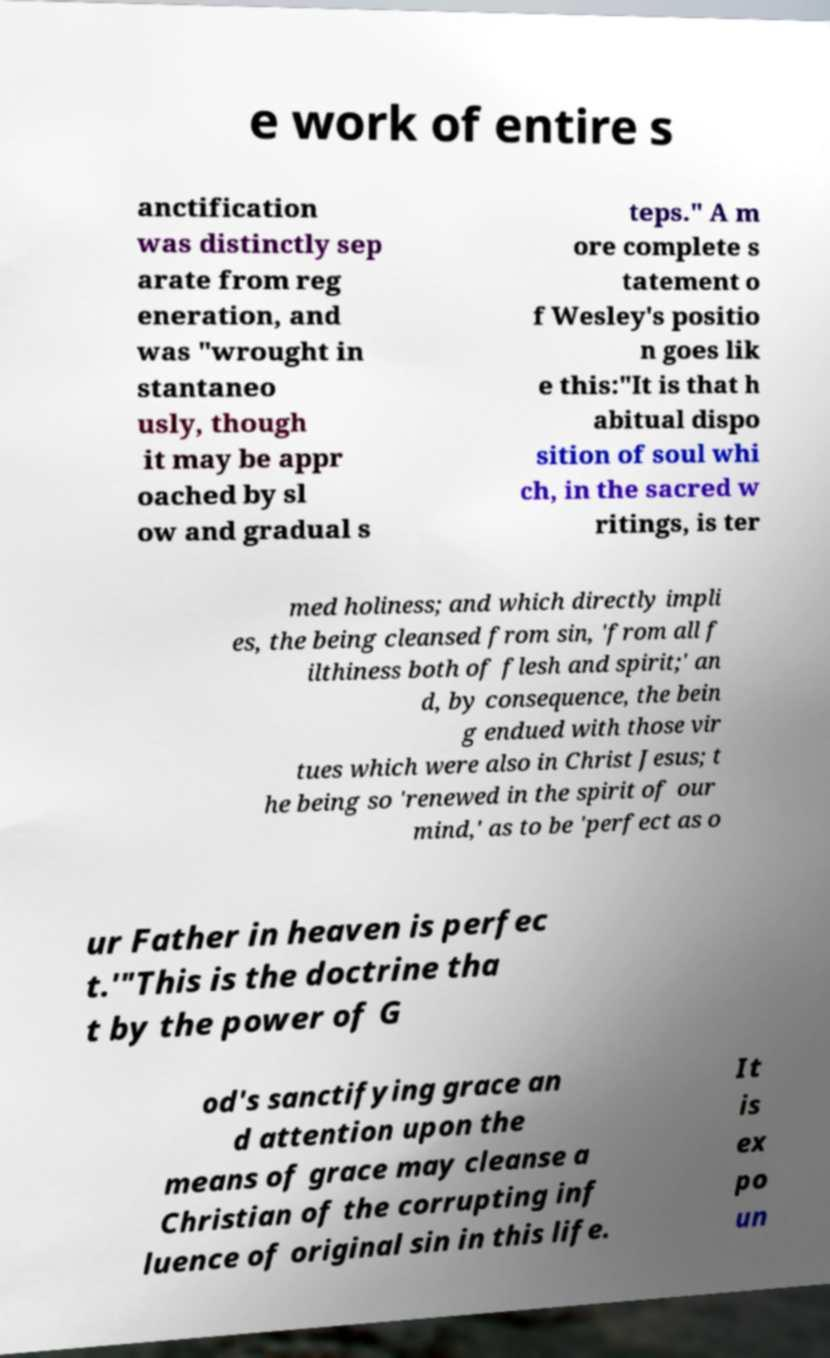For documentation purposes, I need the text within this image transcribed. Could you provide that? e work of entire s anctification was distinctly sep arate from reg eneration, and was "wrought in stantaneo usly, though it may be appr oached by sl ow and gradual s teps." A m ore complete s tatement o f Wesley's positio n goes lik e this:"It is that h abitual dispo sition of soul whi ch, in the sacred w ritings, is ter med holiness; and which directly impli es, the being cleansed from sin, 'from all f ilthiness both of flesh and spirit;' an d, by consequence, the bein g endued with those vir tues which were also in Christ Jesus; t he being so 'renewed in the spirit of our mind,' as to be 'perfect as o ur Father in heaven is perfec t.'"This is the doctrine tha t by the power of G od's sanctifying grace an d attention upon the means of grace may cleanse a Christian of the corrupting inf luence of original sin in this life. It is ex po un 